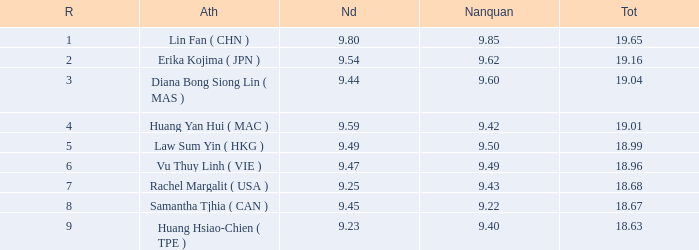Which Nanquan has a Nandao larger than 9.49, and a Rank of 4? 9.42. 